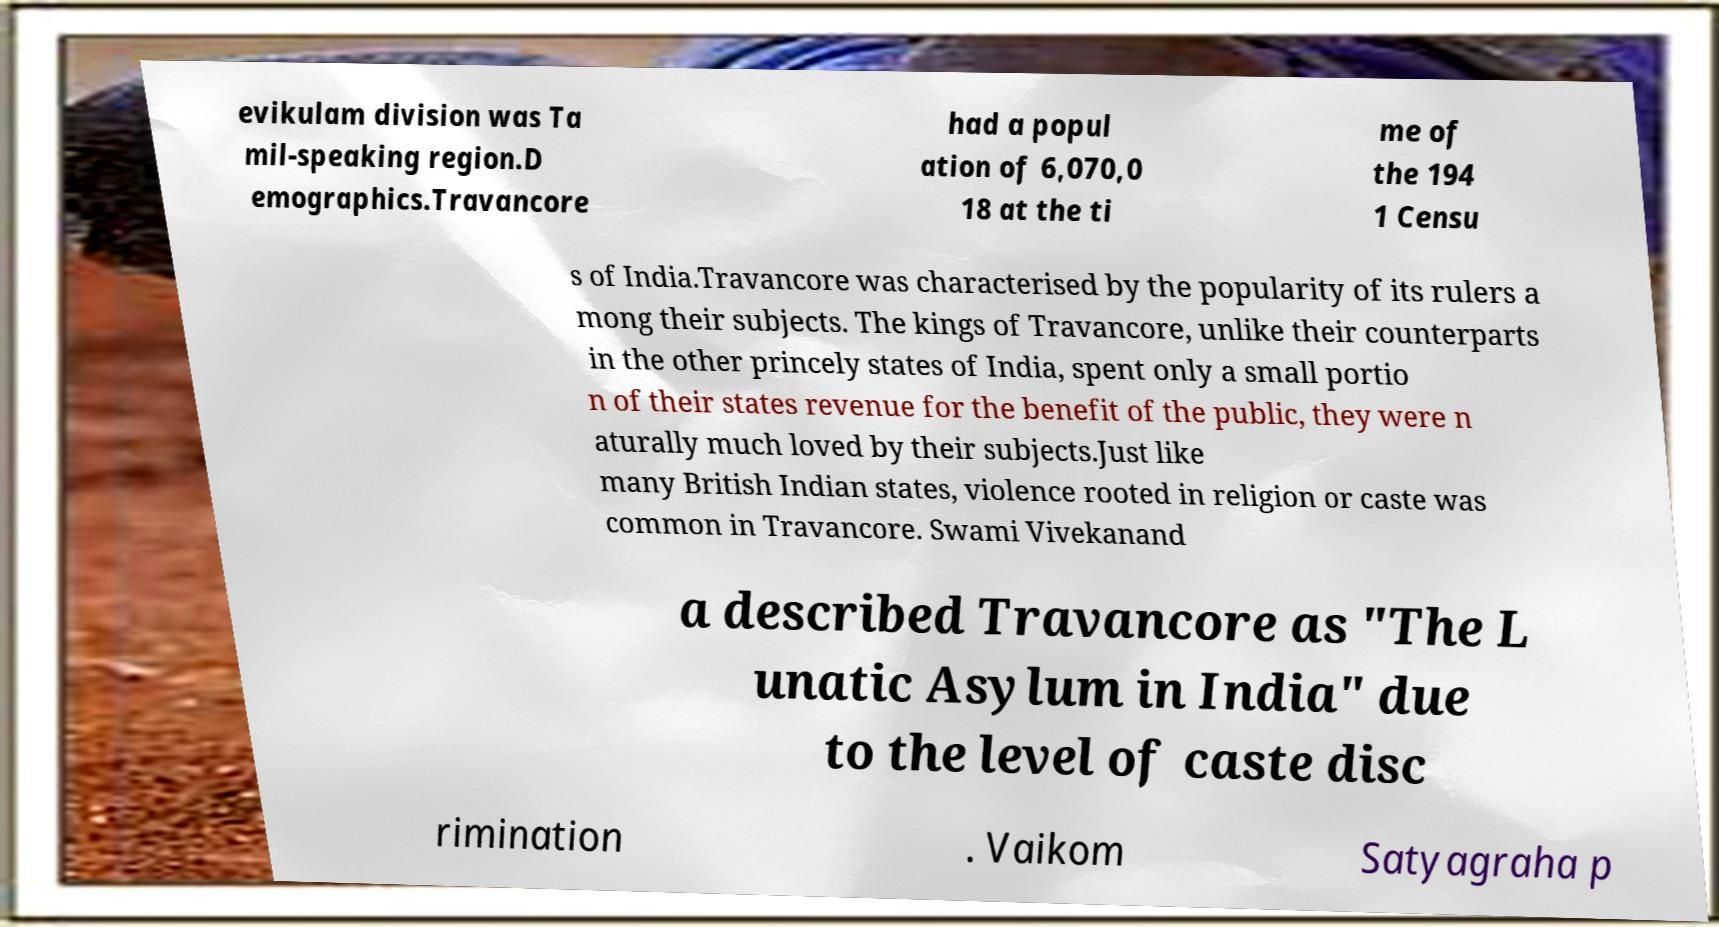Could you extract and type out the text from this image? evikulam division was Ta mil-speaking region.D emographics.Travancore had a popul ation of 6,070,0 18 at the ti me of the 194 1 Censu s of India.Travancore was characterised by the popularity of its rulers a mong their subjects. The kings of Travancore, unlike their counterparts in the other princely states of India, spent only a small portio n of their states revenue for the benefit of the public, they were n aturally much loved by their subjects.Just like many British Indian states, violence rooted in religion or caste was common in Travancore. Swami Vivekanand a described Travancore as "The L unatic Asylum in India" due to the level of caste disc rimination . Vaikom Satyagraha p 